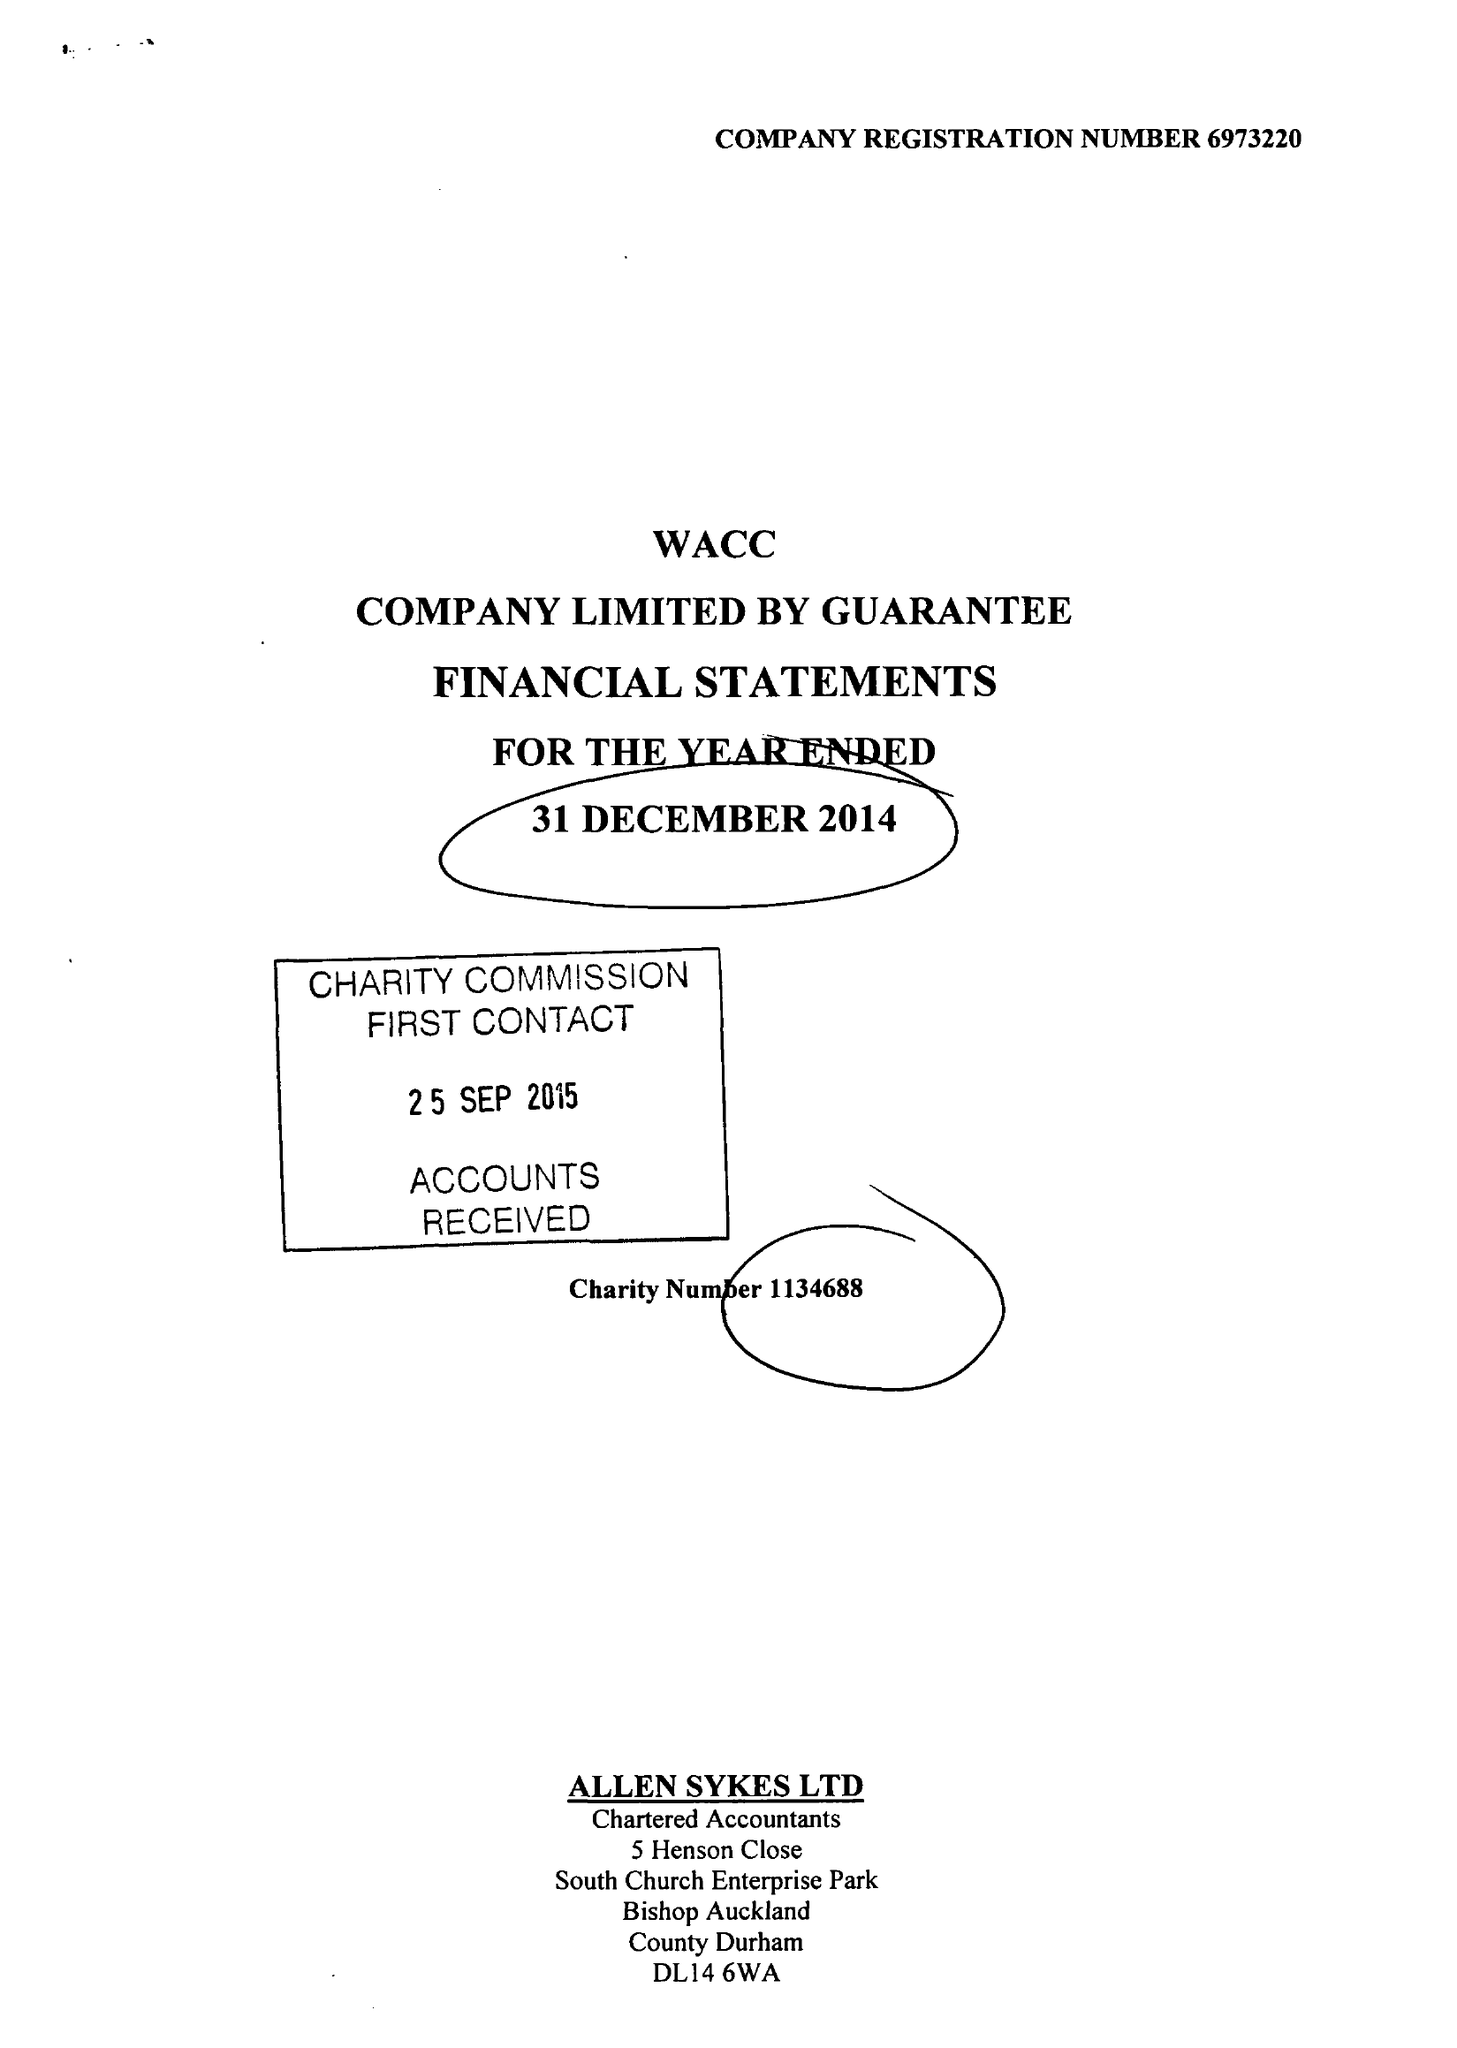What is the value for the address__postcode?
Answer the question using a single word or phrase. DL14 9HJ 